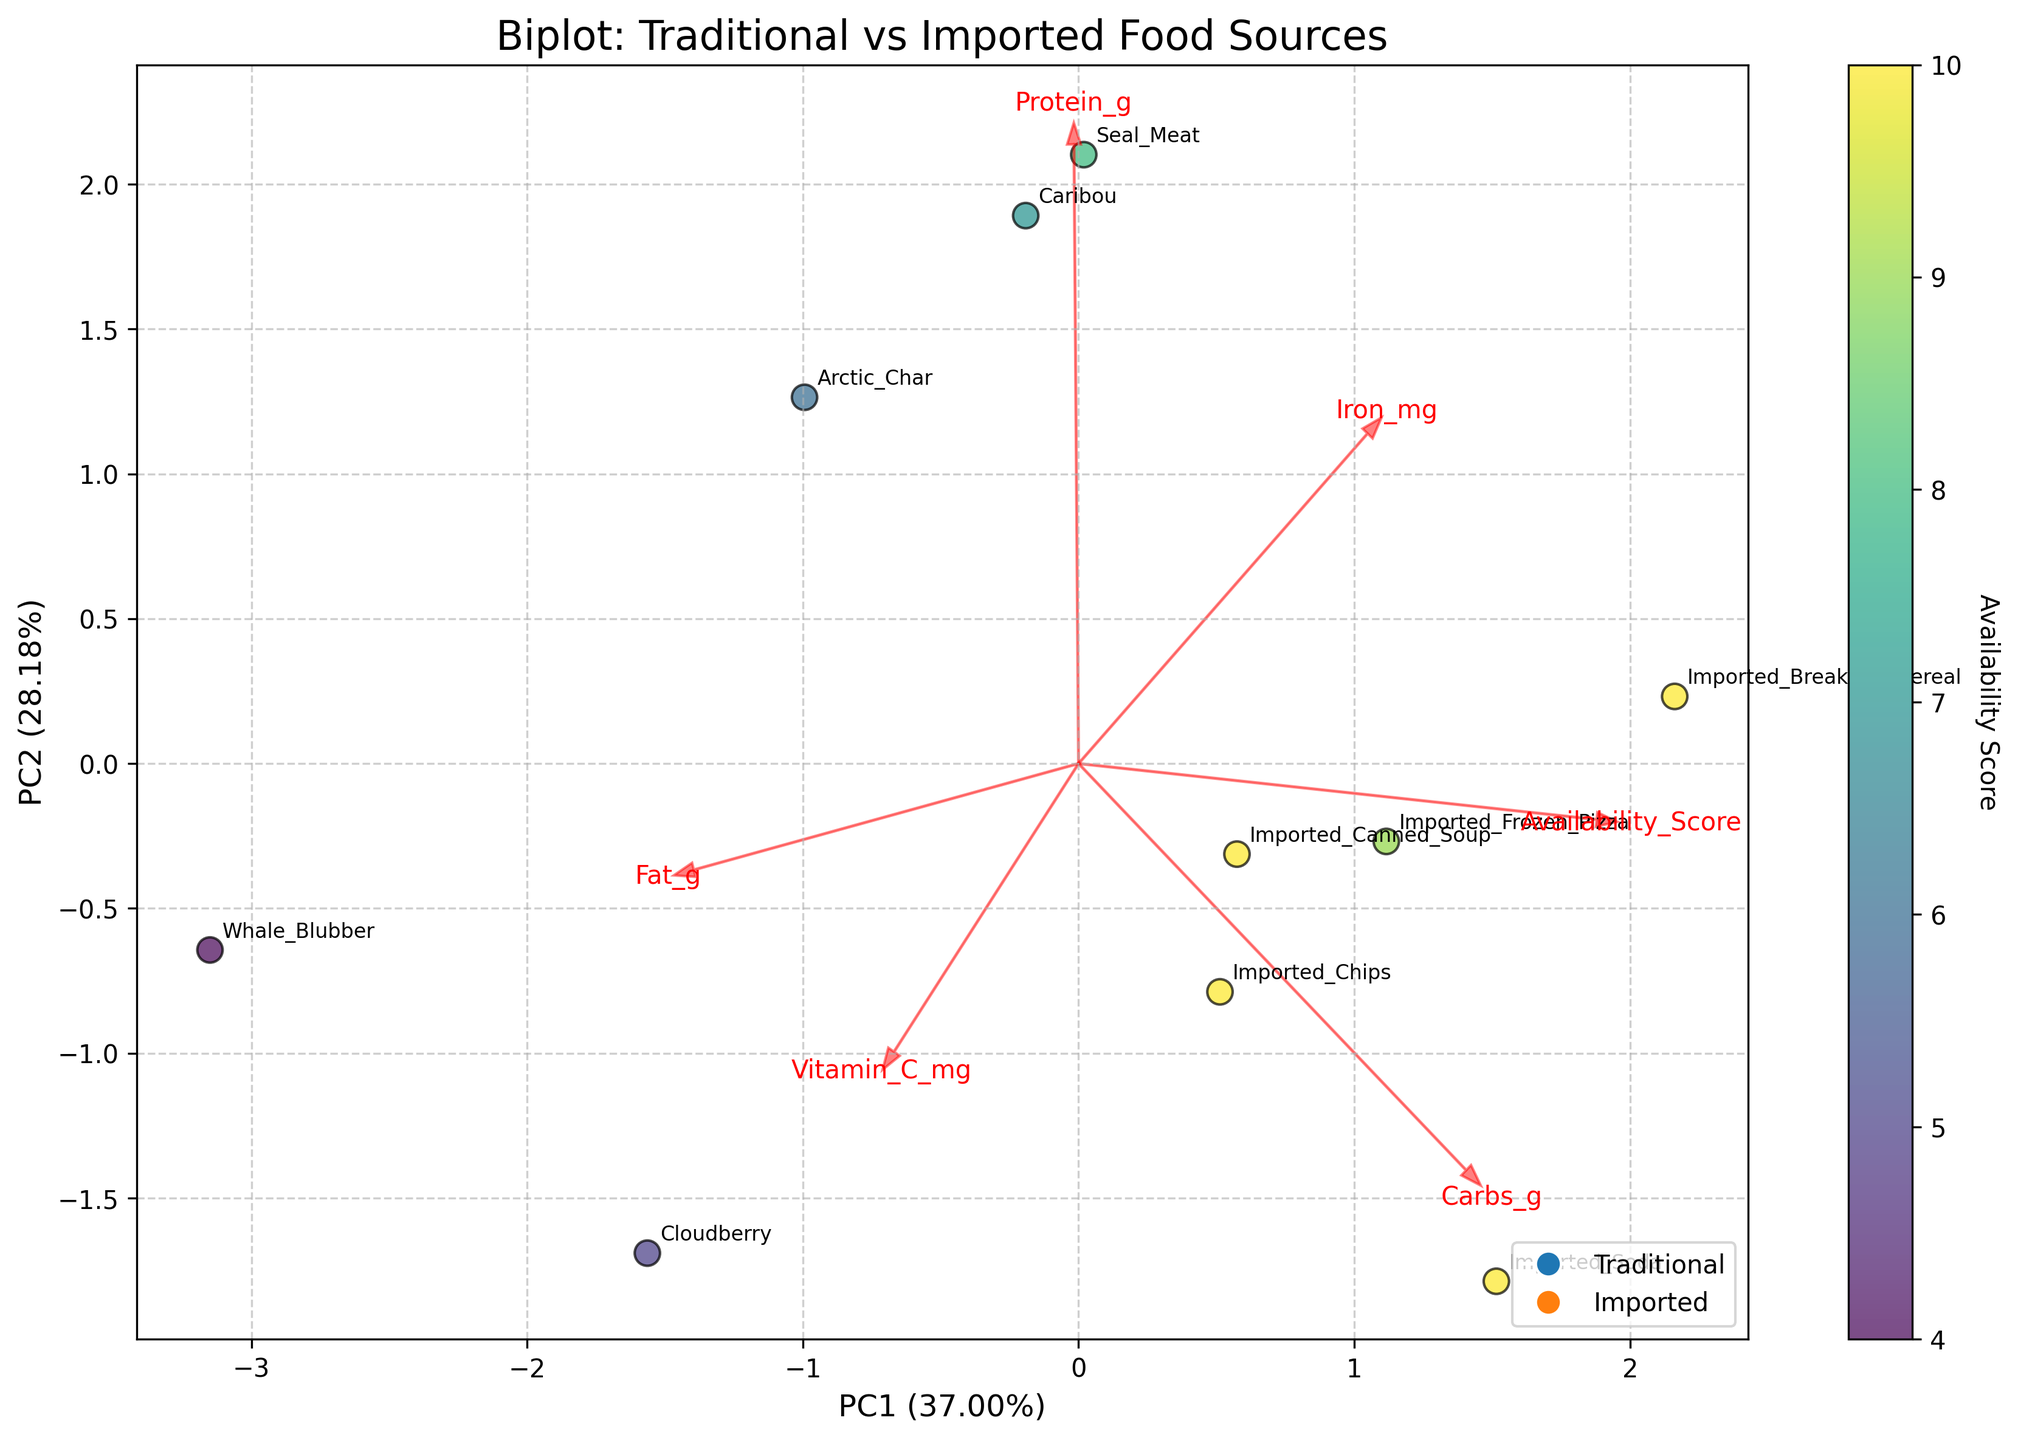How many different food sources are displayed in the plot? There are several points on the biplot, each representing a different food source labeled clearly. Count the labeled points to determine the number of food sources.
Answer: 10 What is the food source with the highest availability score? Observe the color gradient on the plot to identify the food source with the highest score. The imported foods all have the highest availability scores.
Answer: Imported foods (Cereal, Chips, Soda, etc.) Which food source has the highest fat content vector and where is it located on the plot? The longest arrow pointing in the direction of increasing fat content will indicate the highest fat content vector. Whale Blubber should be situated near the end of this arrow.
Answer: Whale Blubber How do traditional food sources compare with imported foods in terms of carbs content? Compare the locations of traditional and imported food sources relative to the carbohydrate content vector. Traditional foods generally cluster near low-carb values, while imported foods are closer to high-carb values.
Answer: Traditional foods have lower carbs Which food source provides the highest amount of Vitamin C, and how is it represented in the plot? Identify the longest arrow pointing in the direction of increasing Vitamin C. The Cloudberry label should be near the end of this arrow.
Answer: Cloudberry Between Seal Meat and Arctic Char, which has a higher protein content and how can you tell? Observe their positions relative to the protein content vector. The point closer to the direction of increasing protein indicates higher content. Seal Meat is closer to this vector compared to Arctic Char.
Answer: Seal Meat What is the direction of the vector representing iron content and which food source is closest to it? Look for the arrow labeled "Iron_mg" and find the food source closest to the end of this arrow. The cereal should be closest to this vector.
Answer: Imported Breakfast Cereal Do imported foods generally cluster together on the biplot? Inspect the plot to see if the points representing imported foods (chips, soda, cereal, etc.) are grouped close to each other compared to the traditional foods. Yes, imported foods tend to form a distinct cluster.
Answer: Yes Which food source combines high availability with significant protein content? Identify the points with high availability scores and then find out which of these has significant protein based on the proximity to the protein vector. The imported frozen pizza offers this combination
Answer: Imported Frozen Pizza Which food source among the traditional foods has the lowest availability score and how is it represented on the plot? Compare the availability scores of traditional foods by their color intensity and identify the point with the least intense color. Whale Blubber has the lowest availability score.
Answer: Whale Blubber 